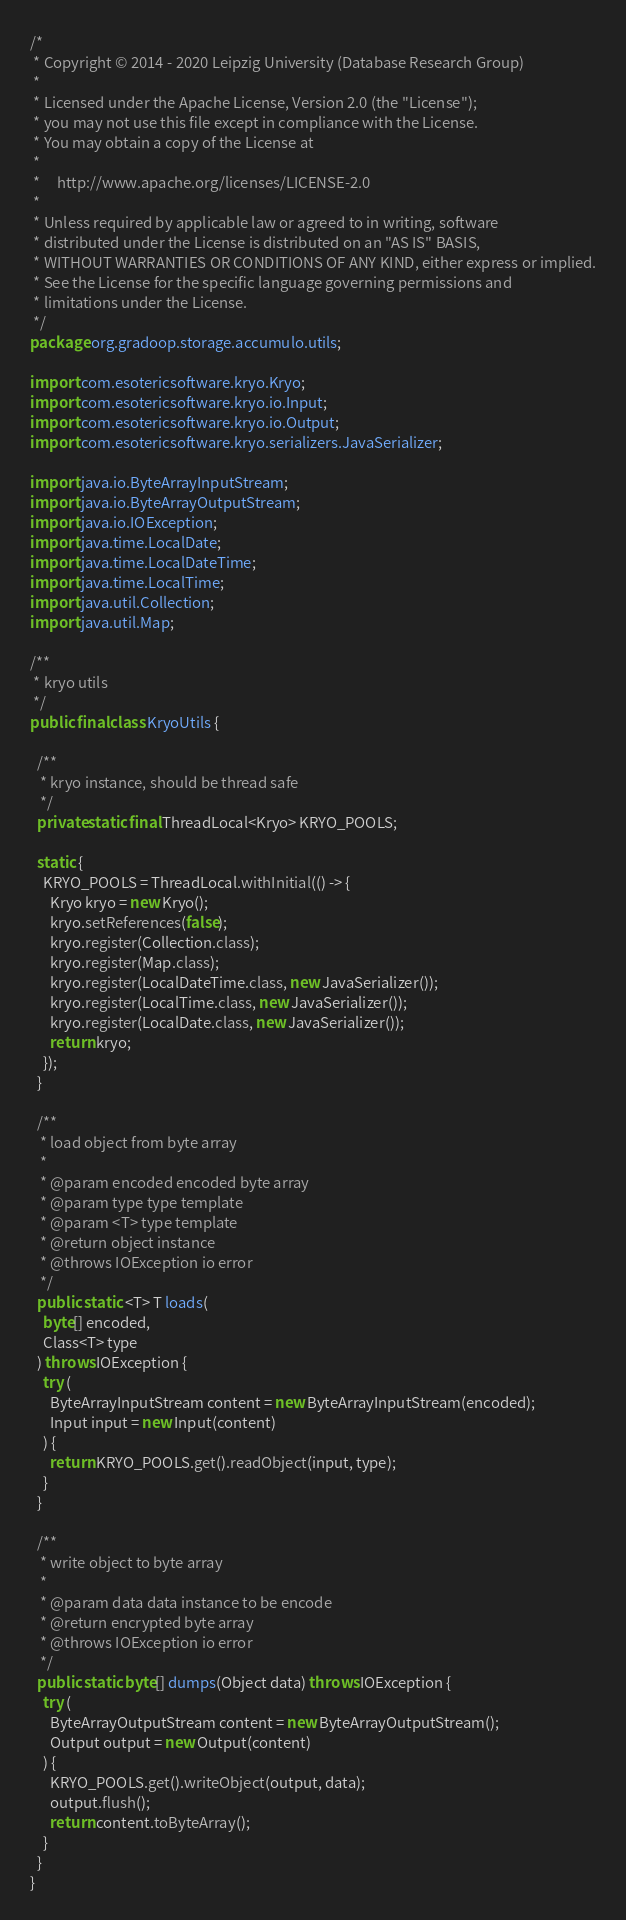Convert code to text. <code><loc_0><loc_0><loc_500><loc_500><_Java_>/*
 * Copyright © 2014 - 2020 Leipzig University (Database Research Group)
 *
 * Licensed under the Apache License, Version 2.0 (the "License");
 * you may not use this file except in compliance with the License.
 * You may obtain a copy of the License at
 *
 *     http://www.apache.org/licenses/LICENSE-2.0
 *
 * Unless required by applicable law or agreed to in writing, software
 * distributed under the License is distributed on an "AS IS" BASIS,
 * WITHOUT WARRANTIES OR CONDITIONS OF ANY KIND, either express or implied.
 * See the License for the specific language governing permissions and
 * limitations under the License.
 */
package org.gradoop.storage.accumulo.utils;

import com.esotericsoftware.kryo.Kryo;
import com.esotericsoftware.kryo.io.Input;
import com.esotericsoftware.kryo.io.Output;
import com.esotericsoftware.kryo.serializers.JavaSerializer;

import java.io.ByteArrayInputStream;
import java.io.ByteArrayOutputStream;
import java.io.IOException;
import java.time.LocalDate;
import java.time.LocalDateTime;
import java.time.LocalTime;
import java.util.Collection;
import java.util.Map;

/**
 * kryo utils
 */
public final class KryoUtils {

  /**
   * kryo instance, should be thread safe
   */
  private static final ThreadLocal<Kryo> KRYO_POOLS;

  static {
    KRYO_POOLS = ThreadLocal.withInitial(() -> {
      Kryo kryo = new Kryo();
      kryo.setReferences(false);
      kryo.register(Collection.class);
      kryo.register(Map.class);
      kryo.register(LocalDateTime.class, new JavaSerializer());
      kryo.register(LocalTime.class, new JavaSerializer());
      kryo.register(LocalDate.class, new JavaSerializer());
      return kryo;
    });
  }

  /**
   * load object from byte array
   *
   * @param encoded encoded byte array
   * @param type type template
   * @param <T> type template
   * @return object instance
   * @throws IOException io error
   */
  public static <T> T loads(
    byte[] encoded,
    Class<T> type
  ) throws IOException {
    try (
      ByteArrayInputStream content = new ByteArrayInputStream(encoded);
      Input input = new Input(content)
    ) {
      return KRYO_POOLS.get().readObject(input, type);
    }
  }

  /**
   * write object to byte array
   *
   * @param data data instance to be encode
   * @return encrypted byte array
   * @throws IOException io error
   */
  public static byte[] dumps(Object data) throws IOException {
    try (
      ByteArrayOutputStream content = new ByteArrayOutputStream();
      Output output = new Output(content)
    ) {
      KRYO_POOLS.get().writeObject(output, data);
      output.flush();
      return content.toByteArray();
    }
  }
}
</code> 